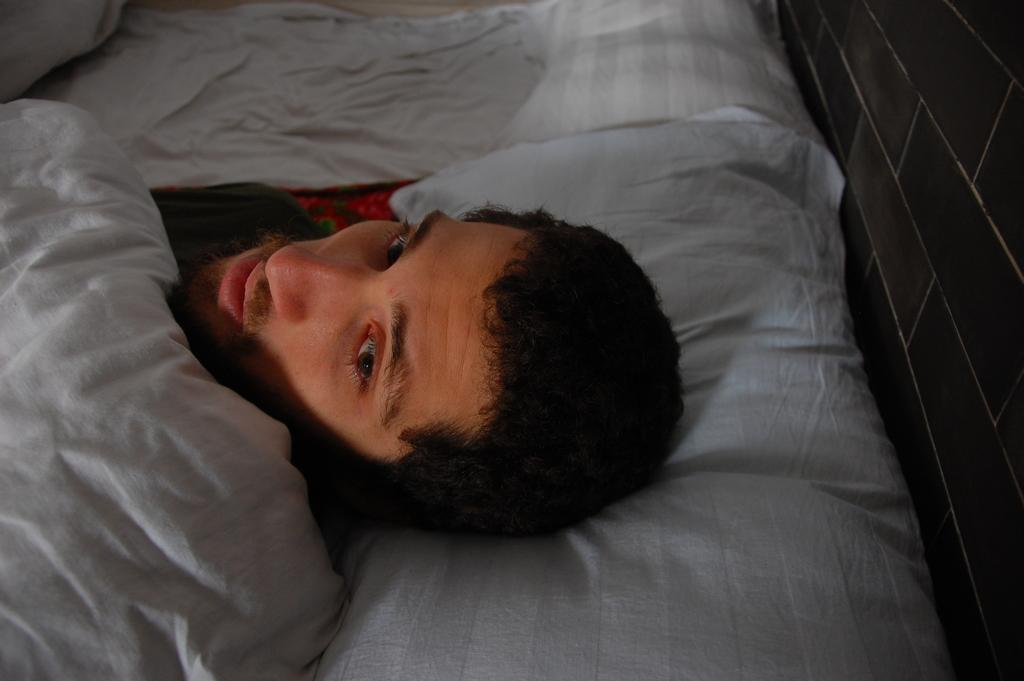What is the person in the image doing? The person in the image is sleeping. Can you describe the person's state of comfort or warmth? There is a blanket on the person. What type of trouble is the person's brother experiencing in the image? There is no reference to a brother or any trouble in the image, so it's not possible to determine what, if any, trouble the brother might be experiencing. 